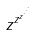<formula> <loc_0><loc_0><loc_500><loc_500>z ^ { z ^ { z ^ { \cdot ^ { \cdot ^ { \cdot } } } } }</formula> 